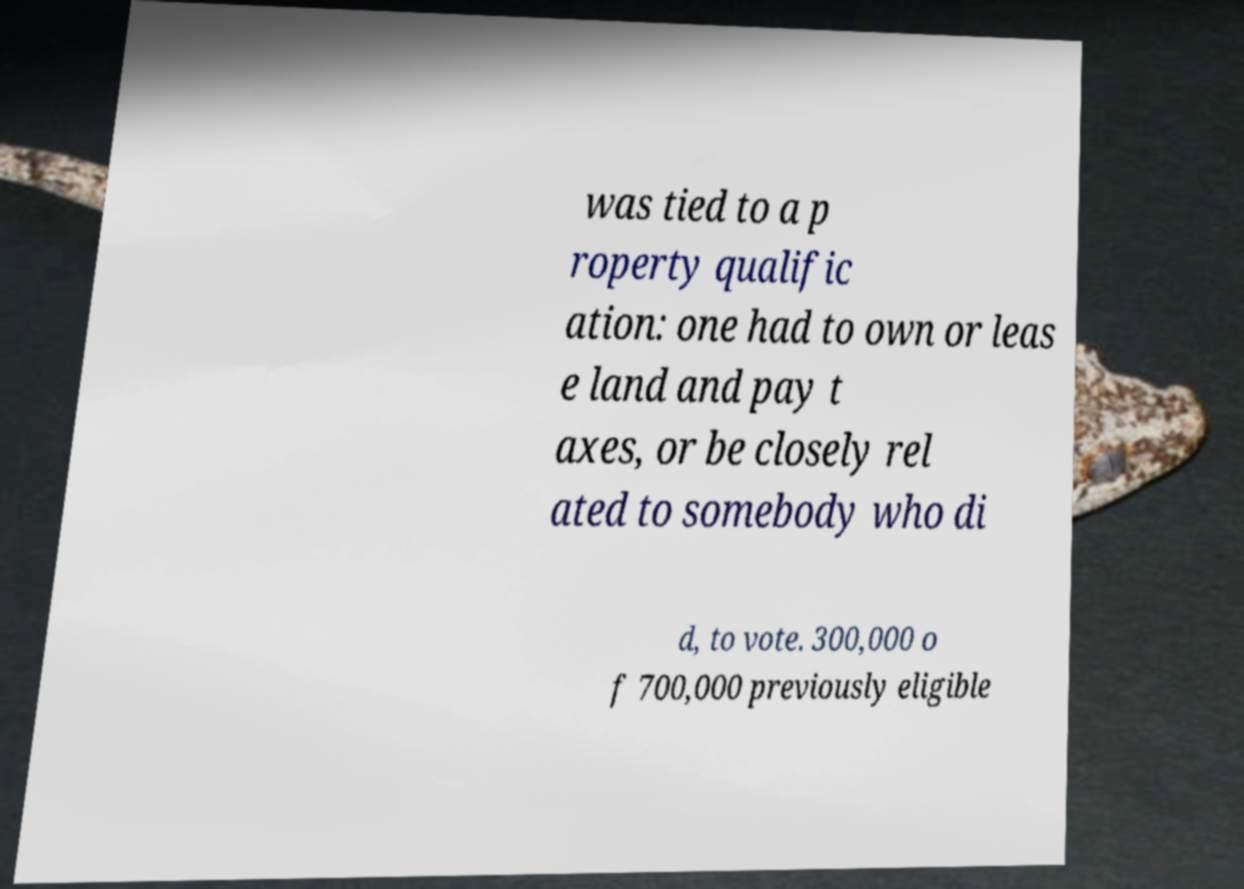There's text embedded in this image that I need extracted. Can you transcribe it verbatim? was tied to a p roperty qualific ation: one had to own or leas e land and pay t axes, or be closely rel ated to somebody who di d, to vote. 300,000 o f 700,000 previously eligible 